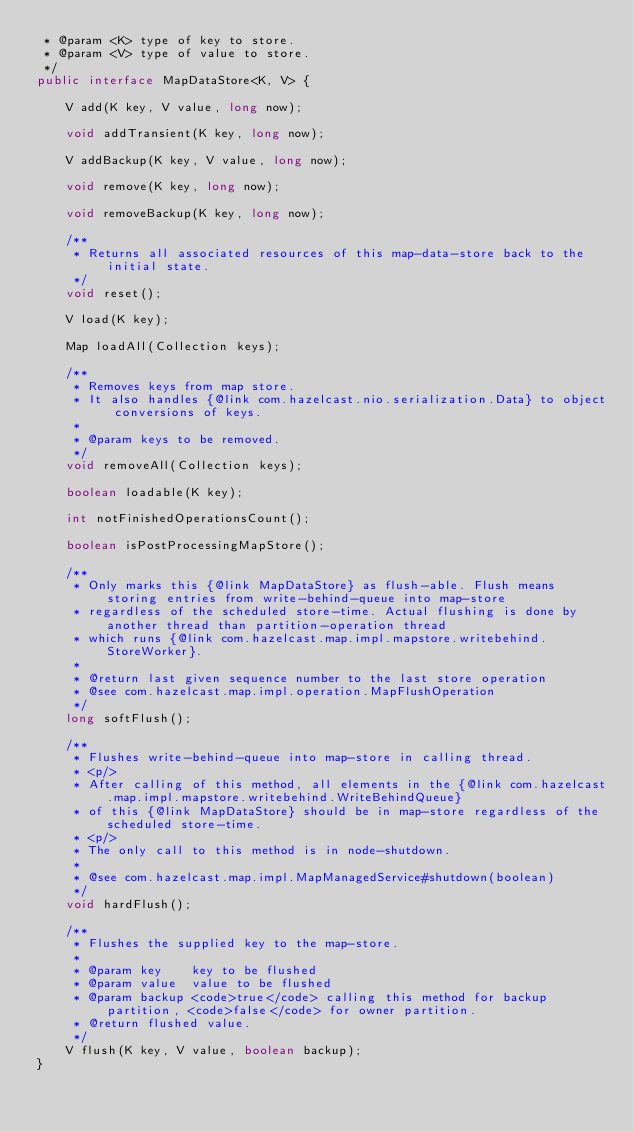Convert code to text. <code><loc_0><loc_0><loc_500><loc_500><_Java_> * @param <K> type of key to store.
 * @param <V> type of value to store.
 */
public interface MapDataStore<K, V> {

    V add(K key, V value, long now);

    void addTransient(K key, long now);

    V addBackup(K key, V value, long now);

    void remove(K key, long now);

    void removeBackup(K key, long now);

    /**
     * Returns all associated resources of this map-data-store back to the initial state.
     */
    void reset();

    V load(K key);

    Map loadAll(Collection keys);

    /**
     * Removes keys from map store.
     * It also handles {@link com.hazelcast.nio.serialization.Data} to object conversions of keys.
     *
     * @param keys to be removed.
     */
    void removeAll(Collection keys);

    boolean loadable(K key);

    int notFinishedOperationsCount();

    boolean isPostProcessingMapStore();

    /**
     * Only marks this {@link MapDataStore} as flush-able. Flush means storing entries from write-behind-queue into map-store
     * regardless of the scheduled store-time. Actual flushing is done by another thread than partition-operation thread
     * which runs {@link com.hazelcast.map.impl.mapstore.writebehind.StoreWorker}.
     *
     * @return last given sequence number to the last store operation
     * @see com.hazelcast.map.impl.operation.MapFlushOperation
     */
    long softFlush();

    /**
     * Flushes write-behind-queue into map-store in calling thread.
     * <p/>
     * After calling of this method, all elements in the {@link com.hazelcast.map.impl.mapstore.writebehind.WriteBehindQueue}
     * of this {@link MapDataStore} should be in map-store regardless of the scheduled store-time.
     * <p/>
     * The only call to this method is in node-shutdown.
     *
     * @see com.hazelcast.map.impl.MapManagedService#shutdown(boolean)
     */
    void hardFlush();

    /**
     * Flushes the supplied key to the map-store.
     *
     * @param key    key to be flushed
     * @param value  value to be flushed
     * @param backup <code>true</code> calling this method for backup partition, <code>false</code> for owner partition.
     * @return flushed value.
     */
    V flush(K key, V value, boolean backup);
}
</code> 